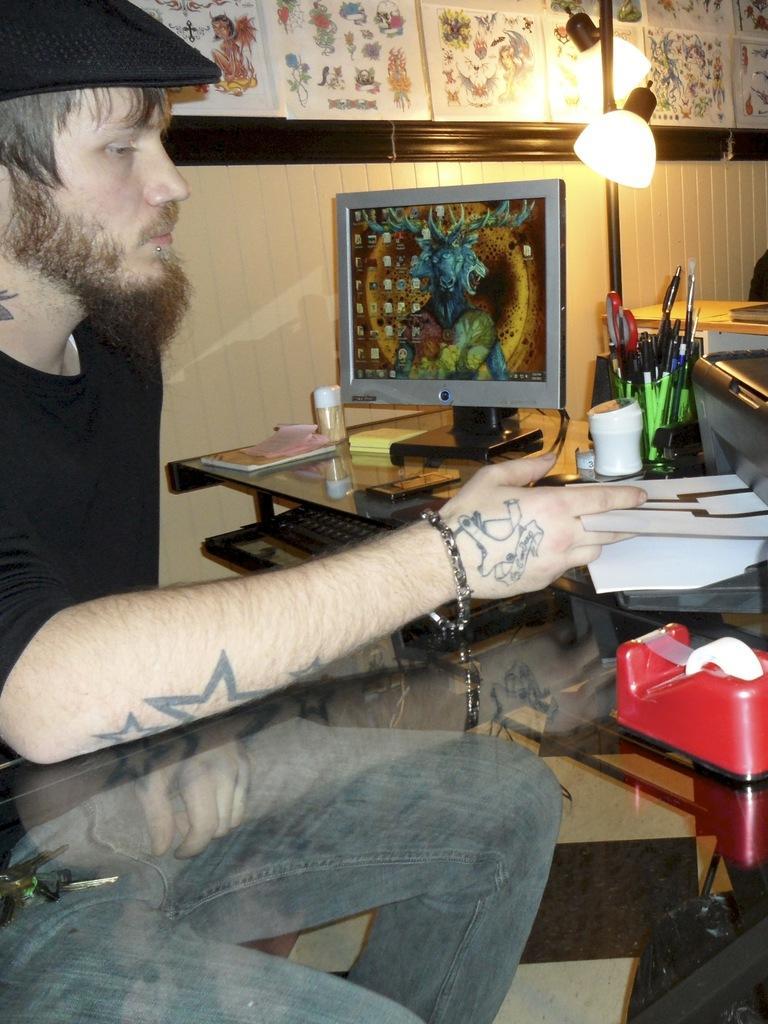Describe this image in one or two sentences. In the middle of the image there is a table, On the table there is a desktop. Beside the desktop there are some pens on the pen holder. Top left side of the image there is a man sitting. Top right side of the image there is a lamp. Behind the lamp there's a wall. 